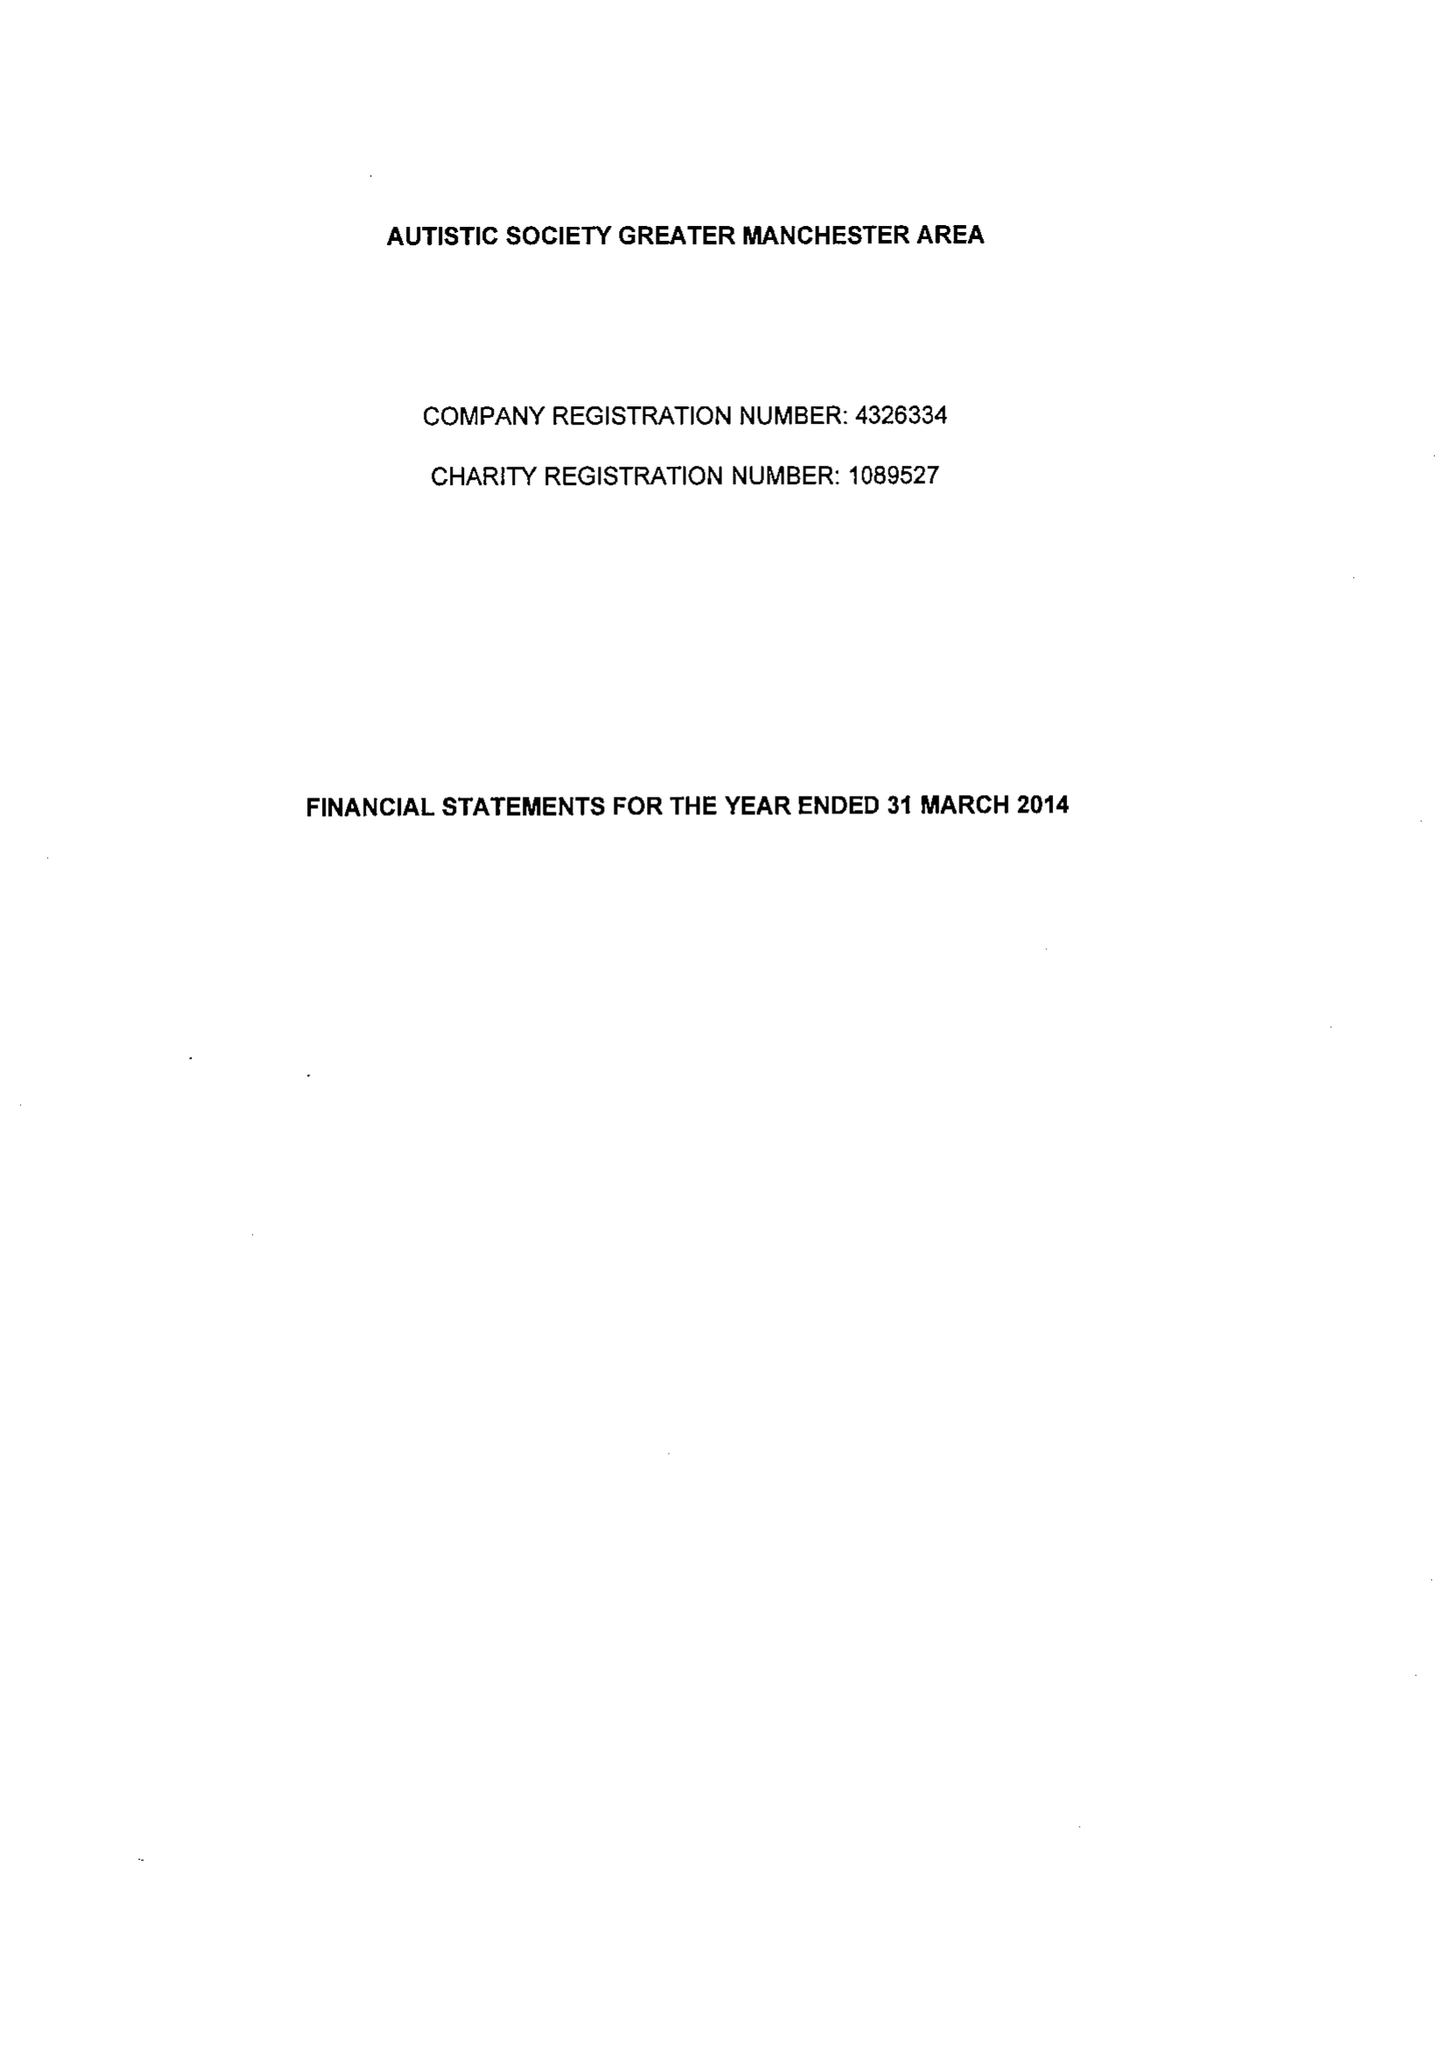What is the value for the charity_name?
Answer the question using a single word or phrase. Autistic Society Greater Manchester Area 